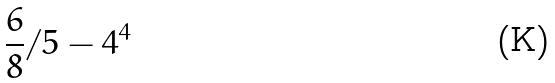<formula> <loc_0><loc_0><loc_500><loc_500>\frac { 6 } { 8 } / 5 - 4 ^ { 4 }</formula> 